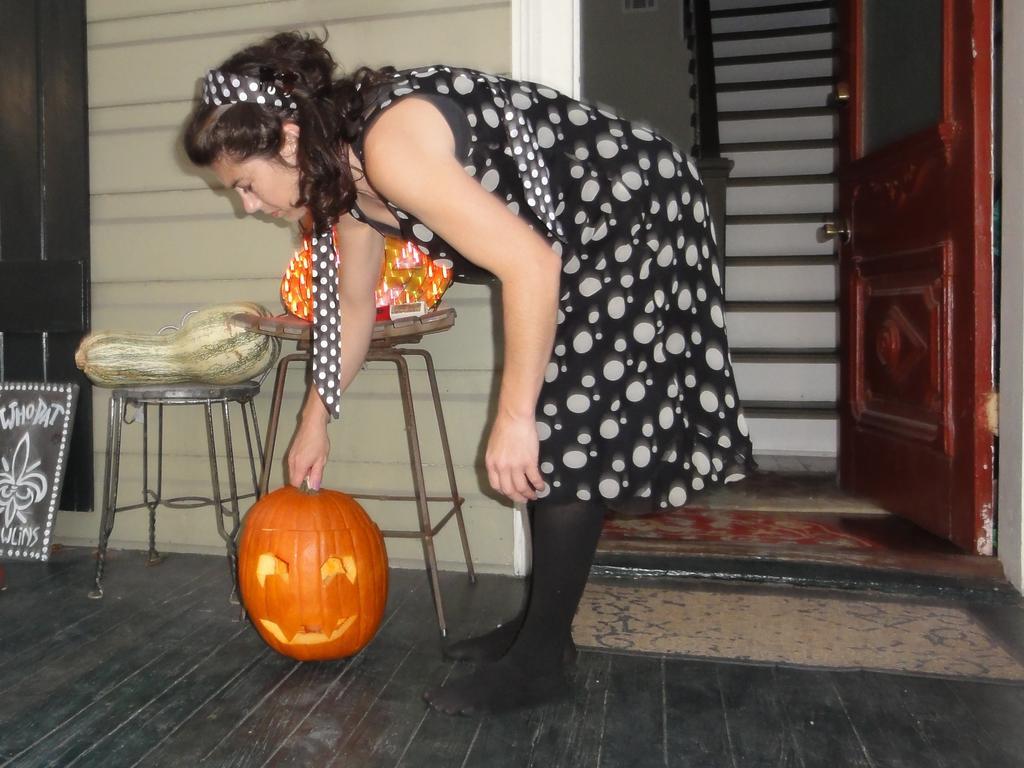Can you describe this image briefly? This picture might be taken inside the room. In this image, in the middle, we can see a woman standing and she is also holding a pumpkin. On the right side, we can see a door which is opened, in the room, we can see a staircase. On the left side, we can see some tables, on that tables, we can see some vegetables, we can also see a black board on the left side and a wall, at the bottom there is a mat. 